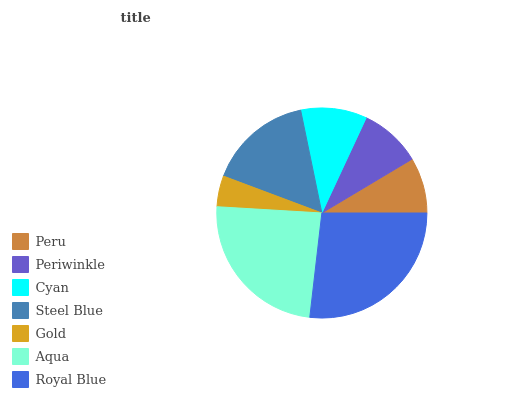Is Gold the minimum?
Answer yes or no. Yes. Is Royal Blue the maximum?
Answer yes or no. Yes. Is Periwinkle the minimum?
Answer yes or no. No. Is Periwinkle the maximum?
Answer yes or no. No. Is Periwinkle greater than Peru?
Answer yes or no. Yes. Is Peru less than Periwinkle?
Answer yes or no. Yes. Is Peru greater than Periwinkle?
Answer yes or no. No. Is Periwinkle less than Peru?
Answer yes or no. No. Is Cyan the high median?
Answer yes or no. Yes. Is Cyan the low median?
Answer yes or no. Yes. Is Periwinkle the high median?
Answer yes or no. No. Is Aqua the low median?
Answer yes or no. No. 